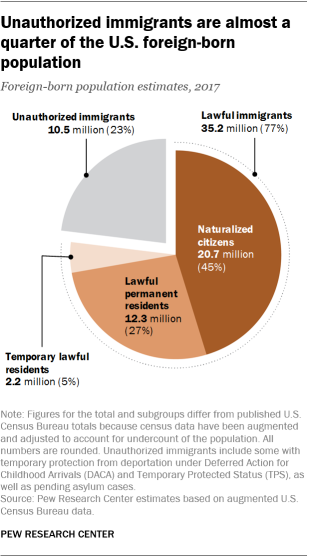Point out several critical features in this image. Based on the graph, it appears that the share of Temporary lawful residents is the lowest among all the categories. According to the U.S. Department of Homeland Security, approximately 0.77% of the foreign-born population in the United States is composed of lawful immigrants. 